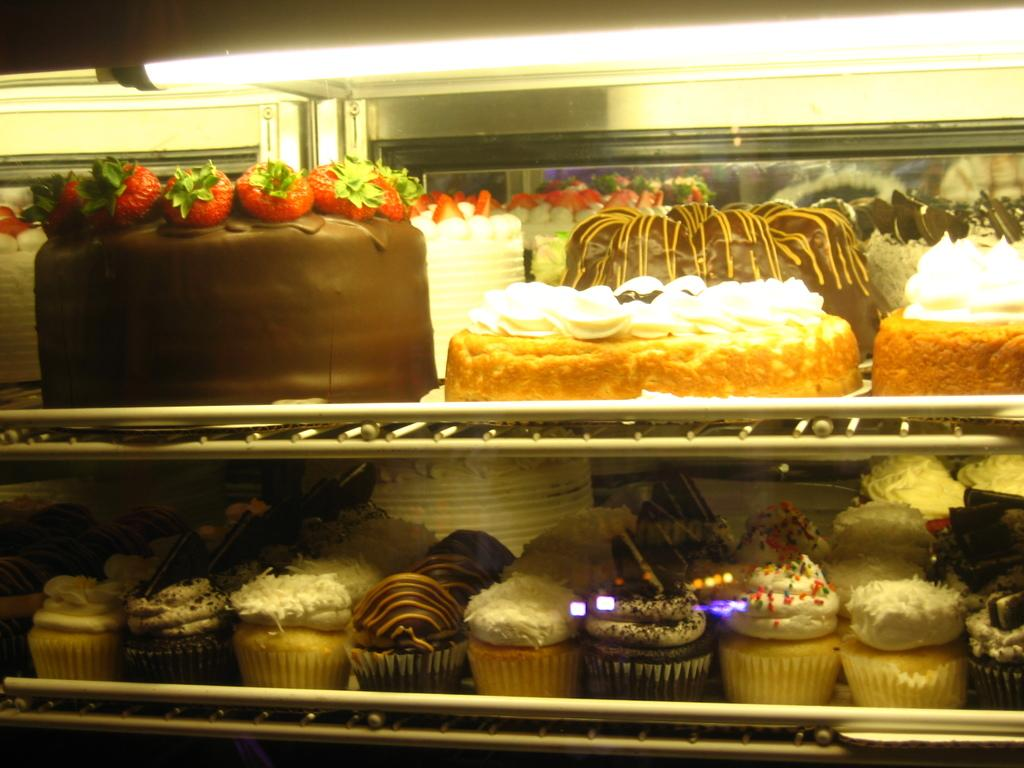What type of dessert can be seen in the image? There are cakes and cupcakes in the image. Can you describe the lighting in the image? There is a light on the top side of the image. How many drawers are visible in the image? There are no drawers present in the image. What type of metal can be seen in the image? There is no metal visible in the image. 